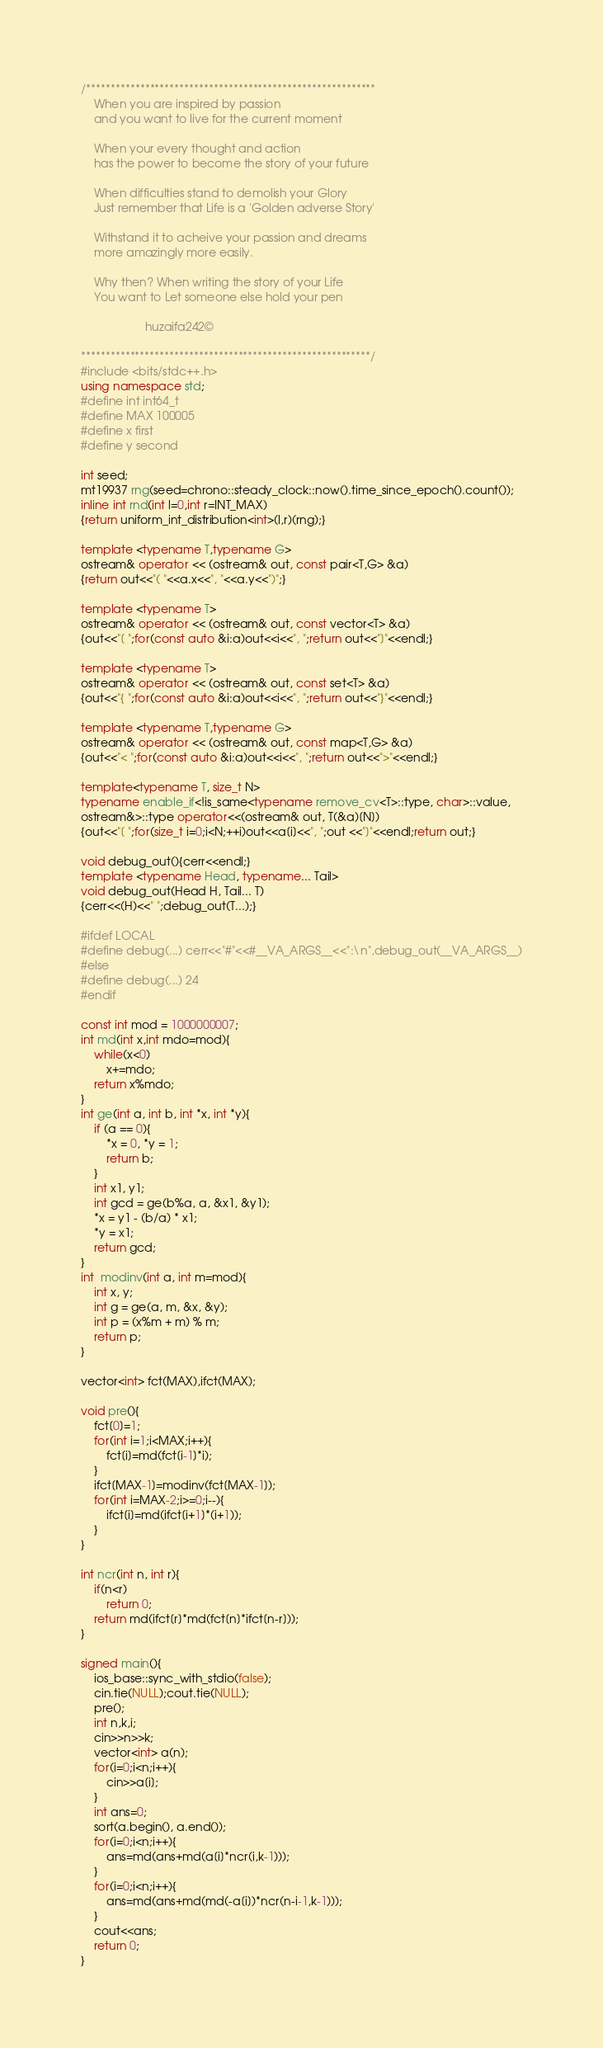<code> <loc_0><loc_0><loc_500><loc_500><_C++_>/***********************************************************
	When you are inspired by passion 
	and you want to live for the current moment

	When your every thought and action
	has the power to become the story of your future

	When difficulties stand to demolish your Glory
	Just remember that Life is a 'Golden adverse Story'

	Withstand it to acheive your passion and dreams
	more amazingly more easily.

	Why then? When writing the story of your Life
	You want to Let someone else hold your pen

					huzaifa242©

***********************************************************/
#include <bits/stdc++.h>
using namespace std;
#define int int64_t
#define MAX 100005
#define x first 
#define y second

int seed;
mt19937 rng(seed=chrono::steady_clock::now().time_since_epoch().count());
inline int rnd(int l=0,int r=INT_MAX)
{return uniform_int_distribution<int>(l,r)(rng);}

template <typename T,typename G>
ostream& operator << (ostream& out, const pair<T,G> &a) 
{return out<<"( "<<a.x<<", "<<a.y<<")";}

template <typename T>
ostream& operator << (ostream& out, const vector<T> &a) 
{out<<"[ ";for(const auto &i:a)out<<i<<", ";return out<<"]"<<endl;}

template <typename T>
ostream& operator << (ostream& out, const set<T> &a) 
{out<<"{ ";for(const auto &i:a)out<<i<<", ";return out<<"}"<<endl;}

template <typename T,typename G>
ostream& operator << (ostream& out, const map<T,G> &a) 
{out<<"< ";for(const auto &i:a)out<<i<<", ";return out<<">"<<endl;}

template<typename T, size_t N>
typename enable_if<!is_same<typename remove_cv<T>::type, char>::value,
ostream&>::type operator<<(ostream& out, T(&a)[N])
{out<<"[ ";for(size_t i=0;i<N;++i)out<<a[i]<<", ";out <<"]"<<endl;return out;}

void debug_out(){cerr<<endl;} 
template <typename Head, typename... Tail>
void debug_out(Head H, Tail... T)
{cerr<<(H)<<" ";debug_out(T...);}
 
#ifdef LOCAL
#define debug(...) cerr<<"#"<<#__VA_ARGS__<<":\n",debug_out(__VA_ARGS__)
#else
#define debug(...) 24
#endif

const int mod = 1000000007;
int md(int x,int mdo=mod){
	while(x<0)
		x+=mdo;
	return x%mdo;
}
int ge(int a, int b, int *x, int *y){
	if (a == 0){
		*x = 0, *y = 1;
		return b;
	}
	int x1, y1;
	int gcd = ge(b%a, a, &x1, &y1);
	*x = y1 - (b/a) * x1;
	*y = x1;
	return gcd;
}
int  modinv(int a, int m=mod){
	int x, y;
	int g = ge(a, m, &x, &y);
	int p = (x%m + m) % m;
	return p;
}

vector<int> fct(MAX),ifct(MAX);

void pre(){
	fct[0]=1;
	for(int i=1;i<MAX;i++){
		fct[i]=md(fct[i-1]*i);
	}
	ifct[MAX-1]=modinv(fct[MAX-1]);
	for(int i=MAX-2;i>=0;i--){
		ifct[i]=md(ifct[i+1]*(i+1));		
	}
}

int ncr(int n, int r){
	if(n<r)
		return 0;
	return md(ifct[r]*md(fct[n]*ifct[n-r]));
}

signed main(){
	ios_base::sync_with_stdio(false);
	cin.tie(NULL);cout.tie(NULL);
	pre();
	int n,k,i;
	cin>>n>>k;
	vector<int> a(n);
	for(i=0;i<n;i++){
		cin>>a[i];
	}
	int ans=0;
	sort(a.begin(), a.end());
	for(i=0;i<n;i++){
		ans=md(ans+md(a[i]*ncr(i,k-1)));
	}
	for(i=0;i<n;i++){
		ans=md(ans+md(md(-a[i])*ncr(n-i-1,k-1)));
	}
	cout<<ans;
	return 0;
}
</code> 